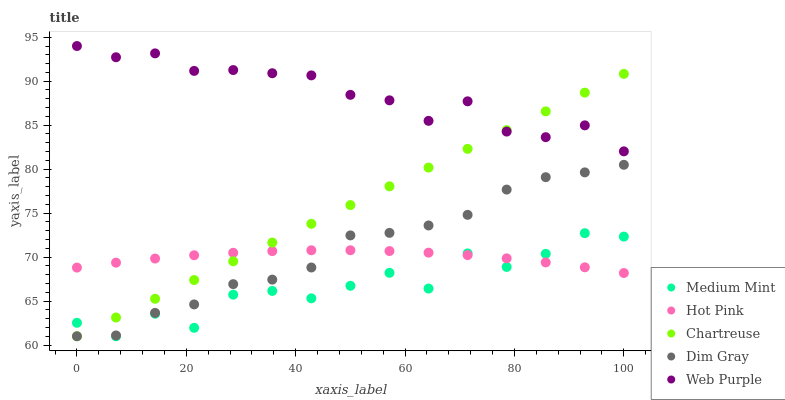Does Medium Mint have the minimum area under the curve?
Answer yes or no. Yes. Does Web Purple have the maximum area under the curve?
Answer yes or no. Yes. Does Chartreuse have the minimum area under the curve?
Answer yes or no. No. Does Chartreuse have the maximum area under the curve?
Answer yes or no. No. Is Chartreuse the smoothest?
Answer yes or no. Yes. Is Medium Mint the roughest?
Answer yes or no. Yes. Is Hot Pink the smoothest?
Answer yes or no. No. Is Hot Pink the roughest?
Answer yes or no. No. Does Medium Mint have the lowest value?
Answer yes or no. Yes. Does Hot Pink have the lowest value?
Answer yes or no. No. Does Web Purple have the highest value?
Answer yes or no. Yes. Does Chartreuse have the highest value?
Answer yes or no. No. Is Dim Gray less than Web Purple?
Answer yes or no. Yes. Is Web Purple greater than Dim Gray?
Answer yes or no. Yes. Does Hot Pink intersect Medium Mint?
Answer yes or no. Yes. Is Hot Pink less than Medium Mint?
Answer yes or no. No. Is Hot Pink greater than Medium Mint?
Answer yes or no. No. Does Dim Gray intersect Web Purple?
Answer yes or no. No. 